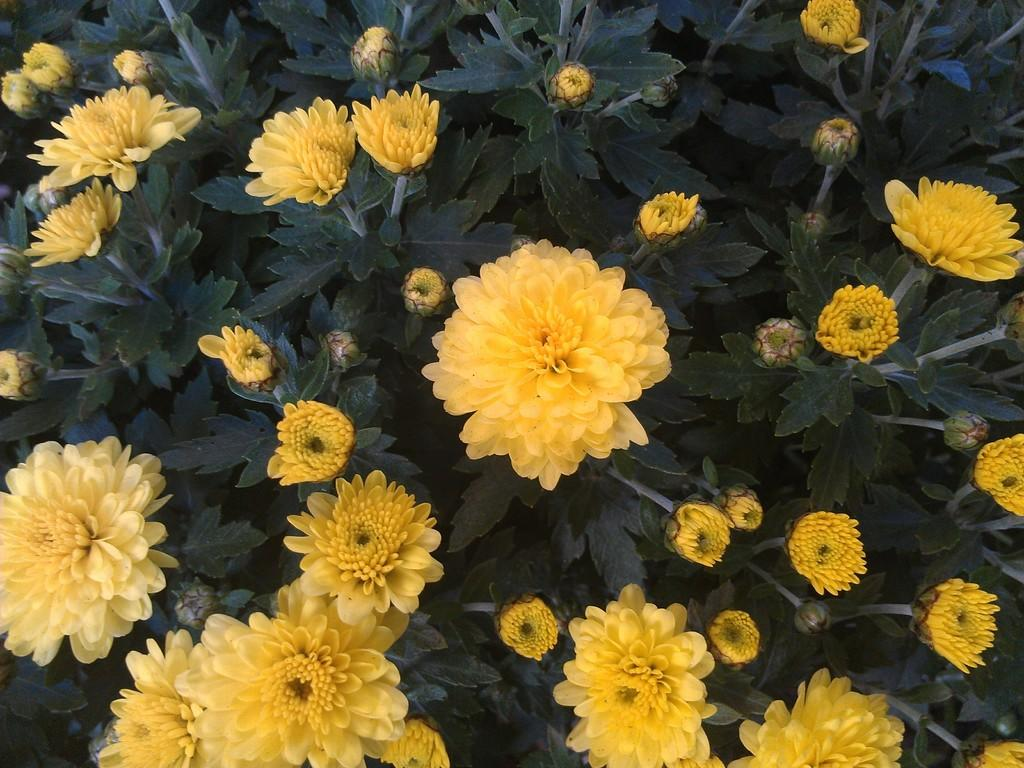What is the predominant color of the flowers in the image? The predominant color of the flowers in the image is yellow. Are the flowers part of a larger plant or arrangement? Yes, the flowers are on a plant. What type of quilt is being used to cover the flowers in the image? There is no quilt present in the image; it features many yellow flowers on a plant. What is the wrist doing in the image? There is no wrist visible in the image, as it focuses on the flowers and the plant. 